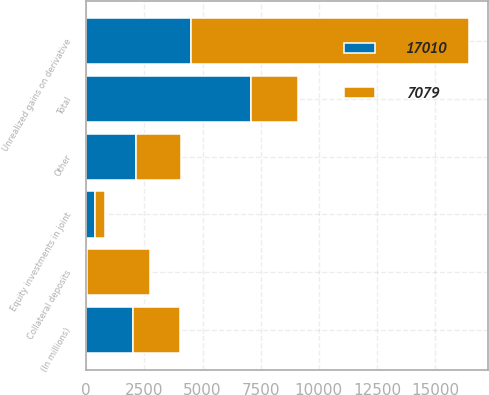Convert chart to OTSL. <chart><loc_0><loc_0><loc_500><loc_500><stacked_bar_chart><ecel><fcel>(In millions)<fcel>Unrealized gains on derivative<fcel>Collateral deposits<fcel>Equity investments in joint<fcel>Other<fcel>Total<nl><fcel>7079<fcel>2008<fcel>11943<fcel>2709<fcel>412<fcel>1946<fcel>2008<nl><fcel>17010<fcel>2007<fcel>4513<fcel>25<fcel>398<fcel>2143<fcel>7079<nl></chart> 